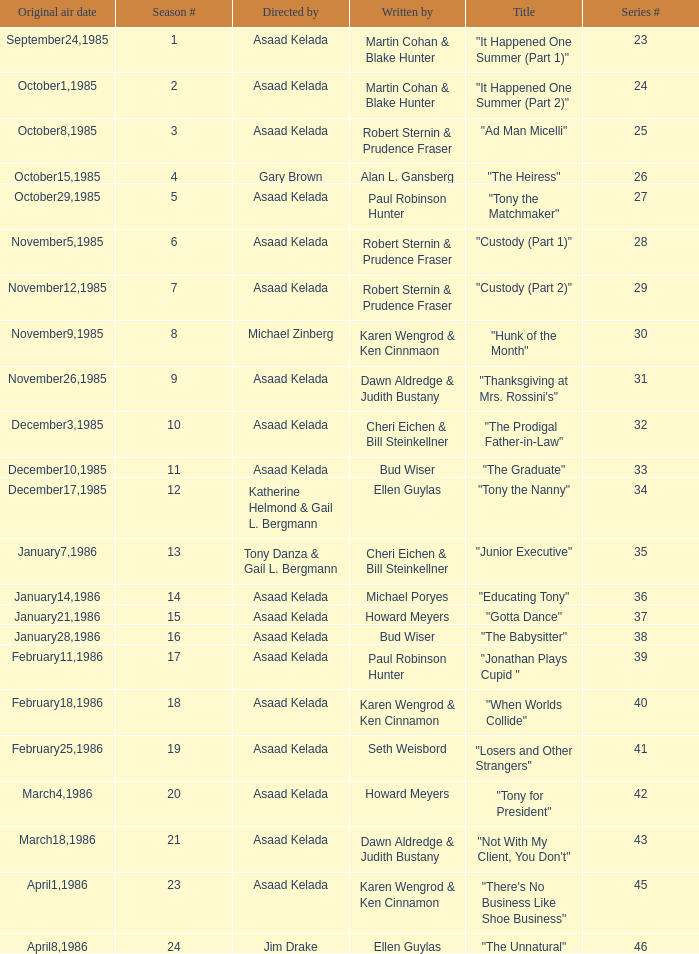Can you give me this table as a dict? {'header': ['Original air date', 'Season #', 'Directed by', 'Written by', 'Title', 'Series #'], 'rows': [['September24,1985', '1', 'Asaad Kelada', 'Martin Cohan & Blake Hunter', '"It Happened One Summer (Part 1)"', '23'], ['October1,1985', '2', 'Asaad Kelada', 'Martin Cohan & Blake Hunter', '"It Happened One Summer (Part 2)"', '24'], ['October8,1985', '3', 'Asaad Kelada', 'Robert Sternin & Prudence Fraser', '"Ad Man Micelli"', '25'], ['October15,1985', '4', 'Gary Brown', 'Alan L. Gansberg', '"The Heiress"', '26'], ['October29,1985', '5', 'Asaad Kelada', 'Paul Robinson Hunter', '"Tony the Matchmaker"', '27'], ['November5,1985', '6', 'Asaad Kelada', 'Robert Sternin & Prudence Fraser', '"Custody (Part 1)"', '28'], ['November12,1985', '7', 'Asaad Kelada', 'Robert Sternin & Prudence Fraser', '"Custody (Part 2)"', '29'], ['November9,1985', '8', 'Michael Zinberg', 'Karen Wengrod & Ken Cinnmaon', '"Hunk of the Month"', '30'], ['November26,1985', '9', 'Asaad Kelada', 'Dawn Aldredge & Judith Bustany', '"Thanksgiving at Mrs. Rossini\'s"', '31'], ['December3,1985', '10', 'Asaad Kelada', 'Cheri Eichen & Bill Steinkellner', '"The Prodigal Father-in-Law"', '32'], ['December10,1985', '11', 'Asaad Kelada', 'Bud Wiser', '"The Graduate"', '33'], ['December17,1985', '12', 'Katherine Helmond & Gail L. Bergmann', 'Ellen Guylas', '"Tony the Nanny"', '34'], ['January7,1986', '13', 'Tony Danza & Gail L. Bergmann', 'Cheri Eichen & Bill Steinkellner', '"Junior Executive"', '35'], ['January14,1986', '14', 'Asaad Kelada', 'Michael Poryes', '"Educating Tony"', '36'], ['January21,1986', '15', 'Asaad Kelada', 'Howard Meyers', '"Gotta Dance"', '37'], ['January28,1986', '16', 'Asaad Kelada', 'Bud Wiser', '"The Babysitter"', '38'], ['February11,1986', '17', 'Asaad Kelada', 'Paul Robinson Hunter', '"Jonathan Plays Cupid "', '39'], ['February18,1986', '18', 'Asaad Kelada', 'Karen Wengrod & Ken Cinnamon', '"When Worlds Collide"', '40'], ['February25,1986', '19', 'Asaad Kelada', 'Seth Weisbord', '"Losers and Other Strangers"', '41'], ['March4,1986', '20', 'Asaad Kelada', 'Howard Meyers', '"Tony for President"', '42'], ['March18,1986', '21', 'Asaad Kelada', 'Dawn Aldredge & Judith Bustany', '"Not With My Client, You Don\'t"', '43'], ['April1,1986', '23', 'Asaad Kelada', 'Karen Wengrod & Ken Cinnamon', '"There\'s No Business Like Shoe Business"', '45'], ['April8,1986', '24', 'Jim Drake', 'Ellen Guylas', '"The Unnatural"', '46']]} Who were the authors of series episode #25? Robert Sternin & Prudence Fraser. 